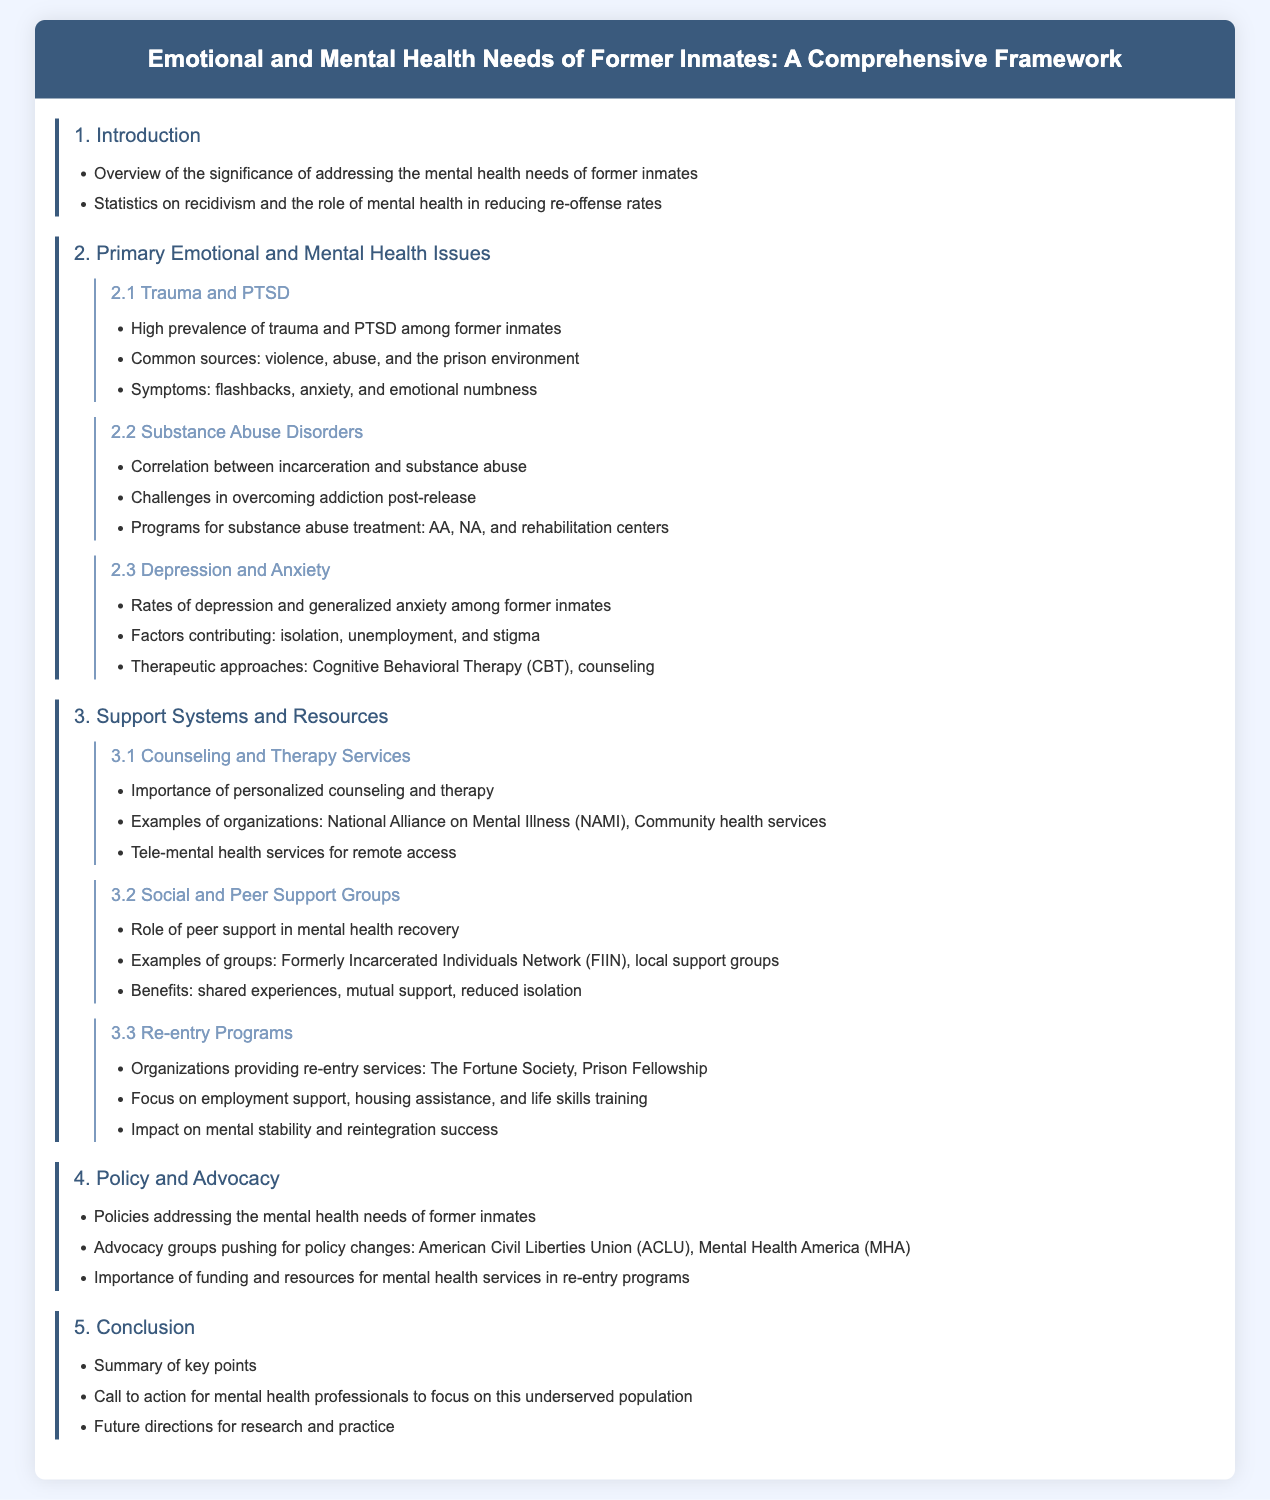What is the primary focus of the document? The document primarily focuses on the emotional and mental health needs of former inmates.
Answer: emotional and mental health needs of former inmates What is one common source of trauma for former inmates? The document lists violence, abuse, and the prison environment as common sources of trauma.
Answer: violence, abuse, and the prison environment What therapeutic approach is mentioned for treating depression and anxiety? Cognitive Behavioral Therapy (CBT) is highlighted as a therapeutic approach for these issues.
Answer: Cognitive Behavioral Therapy (CBT) Which organization is mentioned as providing tele-mental health services? The document provides examples of organizations, specifically noting tele-mental health services for access.
Answer: National Alliance on Mental Illness (NAMI) What are re-entry programs focused on? Re-entry programs are focused on employment support, housing assistance, and life skills training.
Answer: employment support, housing assistance, and life skills training Which advocacy group is mentioned in relation to policy changes? The American Civil Liberties Union (ACLU) is noted as an advocacy group pushing for policy changes.
Answer: American Civil Liberties Union (ACLU) What is a key point summarized in the conclusion? The conclusion summarizes the key points discussed throughout the document.
Answer: Summary of key points How many primary emotional and mental health issues are discussed? The document identifies three primary issues: trauma and PTSD, substance abuse disorders, and depression/anxiety.
Answer: three 